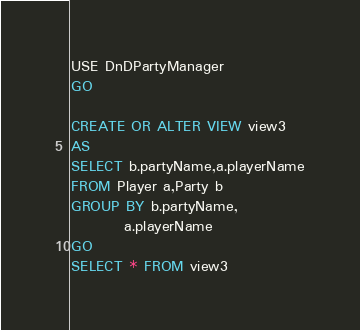<code> <loc_0><loc_0><loc_500><loc_500><_SQL_>USE DnDPartyManager
GO

CREATE OR ALTER VIEW view3
AS
SELECT b.partyName,a.playerName
FROM Player a,Party b
GROUP BY b.partyName,
		 a.playerName
GO
SELECT * FROM view3</code> 